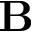Convert formula to latex. <formula><loc_0><loc_0><loc_500><loc_500>B</formula> 